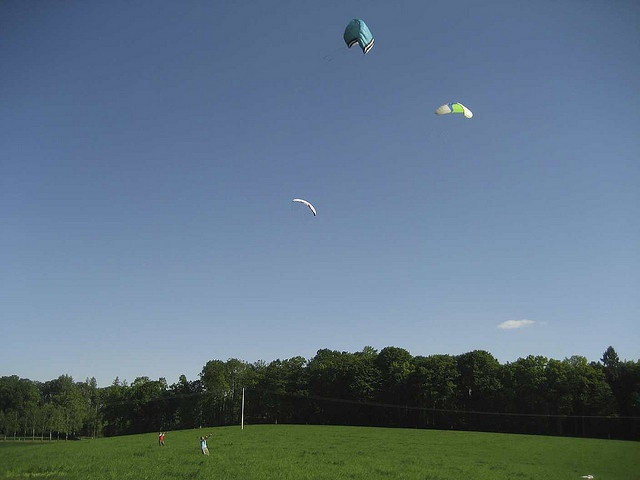Describe the objects in this image and their specific colors. I can see kite in darkblue, blue, black, lightblue, and gray tones, kite in darkblue, ivory, darkgray, lightgreen, and beige tones, kite in darkblue, gray, white, and darkgray tones, people in darkblue, black, gray, darkgreen, and darkgray tones, and people in darkblue, darkgreen, black, gray, and brown tones in this image. 